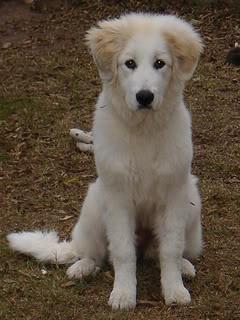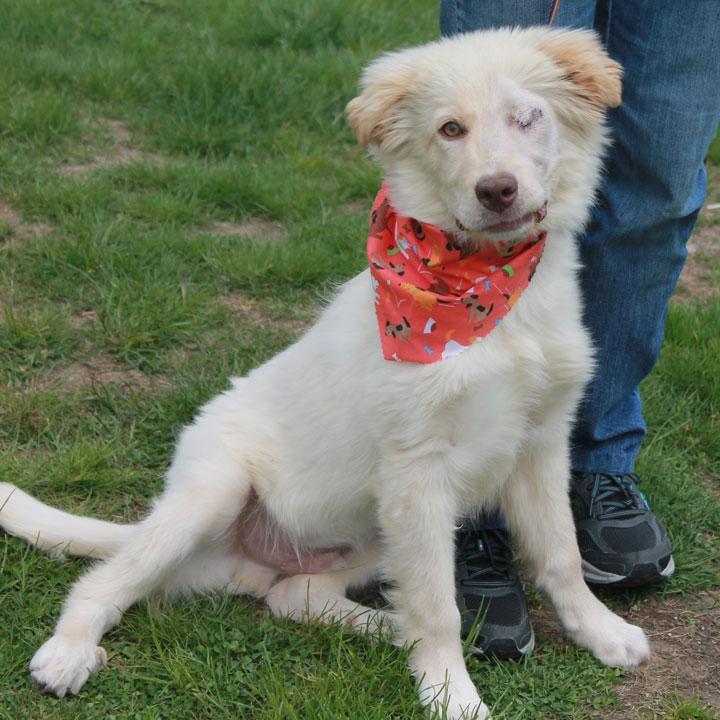The first image is the image on the left, the second image is the image on the right. Assess this claim about the two images: "There is a human holding a dog in the image on the right.". Correct or not? Answer yes or no. No. The first image is the image on the left, the second image is the image on the right. For the images displayed, is the sentence "A man is standing while holding a big white dog." factually correct? Answer yes or no. No. 